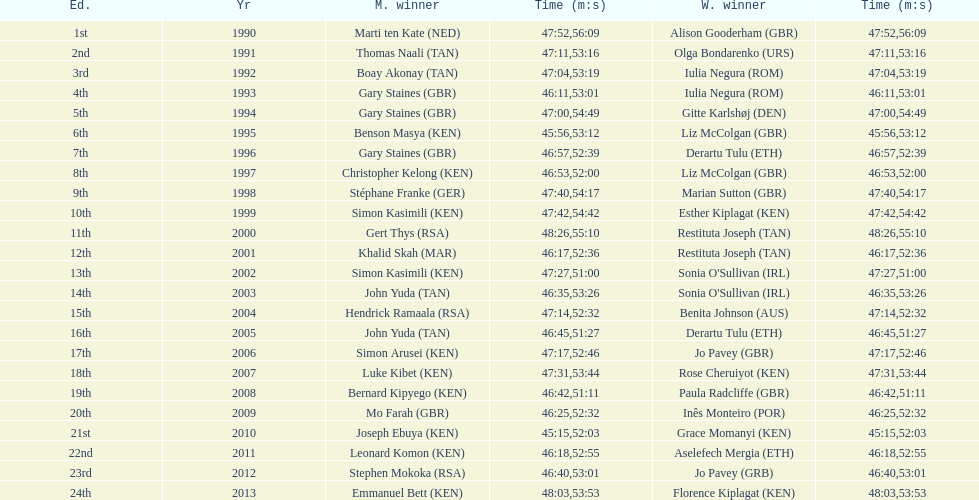Number of men's winners with a finish time under 46:58 12. 